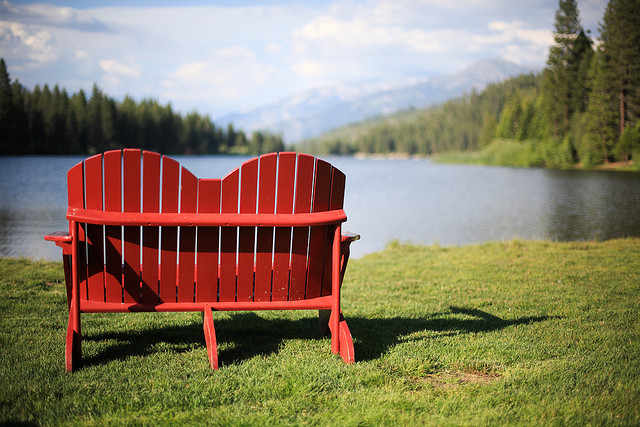Imagine the type of wildlife that might inhabit this area. This area is likely home to a variety of wildlife, including birds like eagles and herons, small mammals such as squirrels and rabbits, and perhaps even deer that come to the lake to drink. The dense forest and pristine lake create a perfect habitat for these animals, and if you sit quietly on the bench long enough, you might have the chance to observe some of them. 